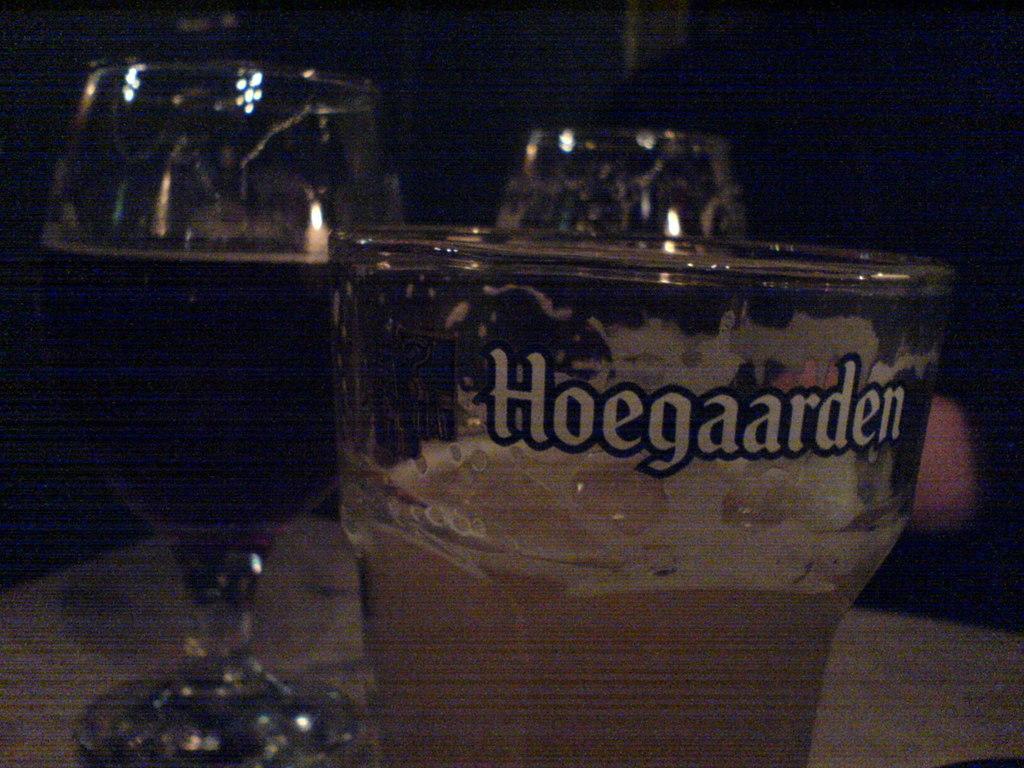What kind of beer is this?
Provide a short and direct response. Hoegaarden. 